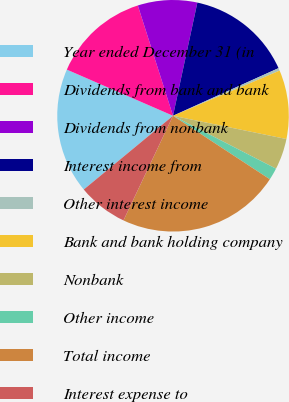<chart> <loc_0><loc_0><loc_500><loc_500><pie_chart><fcel>Year ended December 31 (in<fcel>Dividends from bank and bank<fcel>Dividends from nonbank<fcel>Interest income from<fcel>Other interest income<fcel>Bank and bank holding company<fcel>Nonbank<fcel>Other income<fcel>Total income<fcel>Interest expense to<nl><fcel>17.52%<fcel>13.56%<fcel>8.29%<fcel>14.88%<fcel>0.37%<fcel>9.6%<fcel>4.33%<fcel>1.69%<fcel>22.8%<fcel>6.97%<nl></chart> 